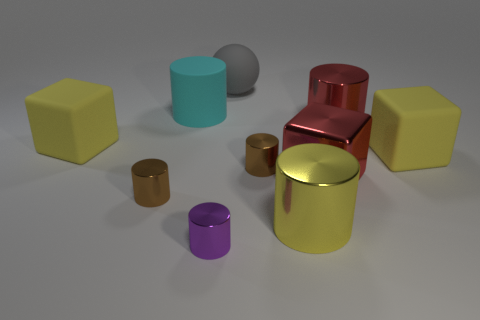Subtract all red cylinders. How many cylinders are left? 5 Subtract all small brown metallic cylinders. How many cylinders are left? 4 Subtract all yellow cylinders. Subtract all cyan blocks. How many cylinders are left? 5 Subtract all cylinders. How many objects are left? 4 Add 6 yellow matte objects. How many yellow matte objects exist? 8 Subtract 1 cyan cylinders. How many objects are left? 9 Subtract all large red balls. Subtract all large red cylinders. How many objects are left? 9 Add 1 large cyan rubber objects. How many large cyan rubber objects are left? 2 